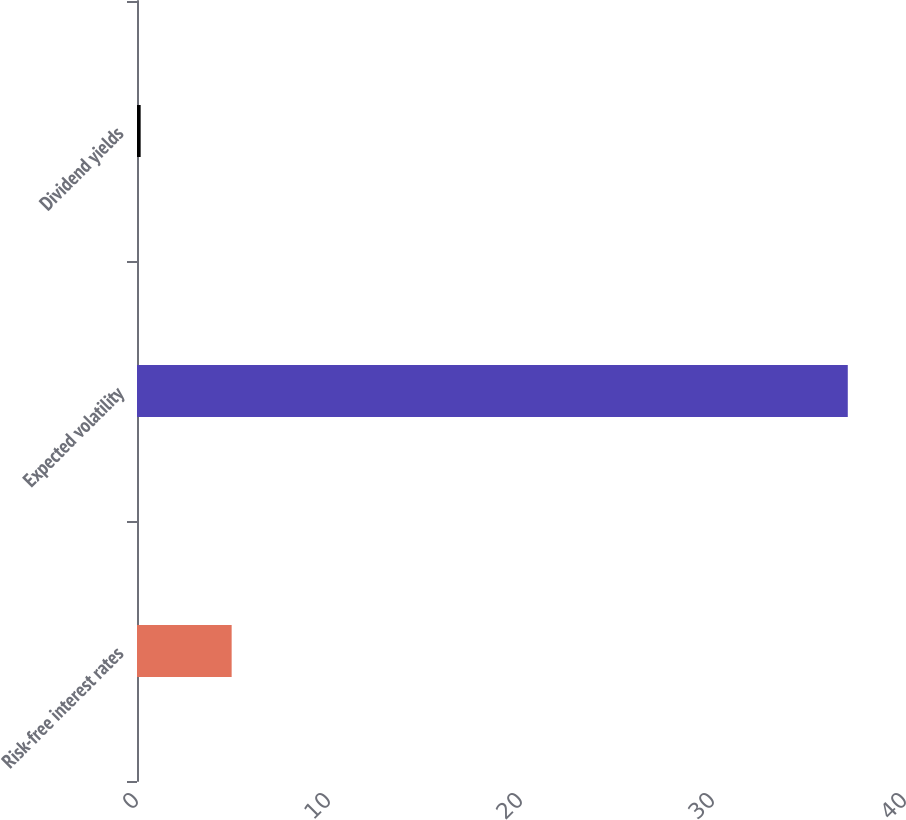Convert chart to OTSL. <chart><loc_0><loc_0><loc_500><loc_500><bar_chart><fcel>Risk-free interest rates<fcel>Expected volatility<fcel>Dividend yields<nl><fcel>4.93<fcel>37.02<fcel>0.19<nl></chart> 